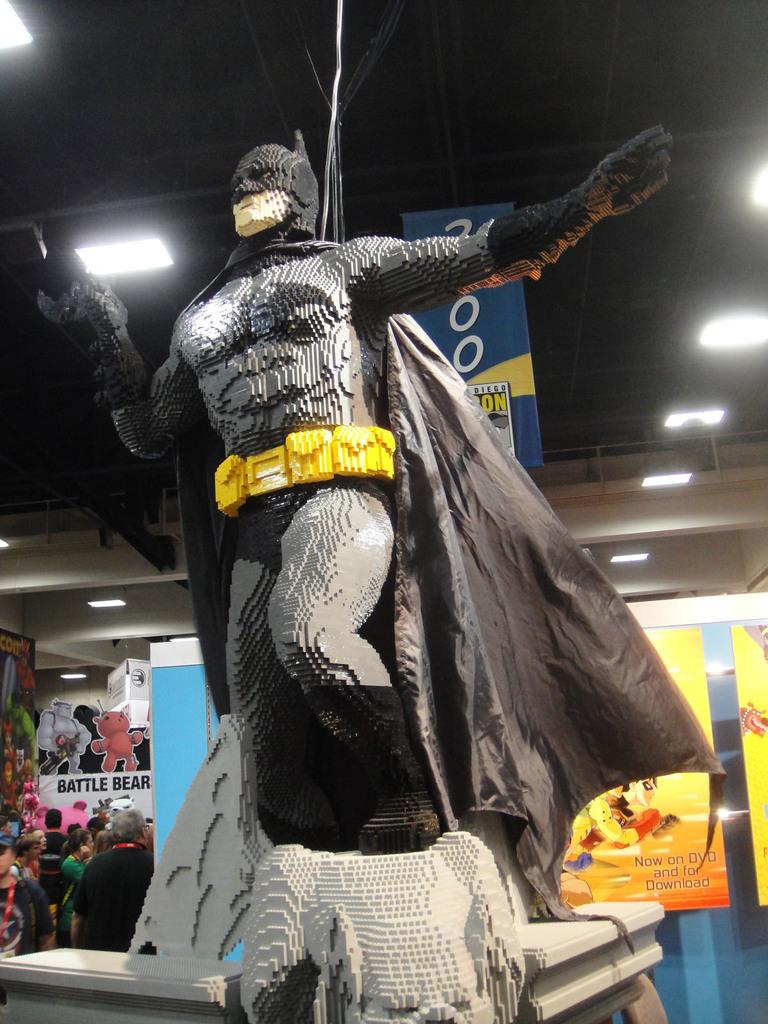What is the main subject in the image? There is a statue in the image. How is the statue positioned in the image? The statue is on a platform. What can be seen in the background of the image? There are people, posters, lights, rods, and some objects in the background of the image. What time is depicted on the patch in the image? There is no patch present in the image, and therefore no time can be determined. How many trucks are visible in the image? There are no trucks visible in the image. 